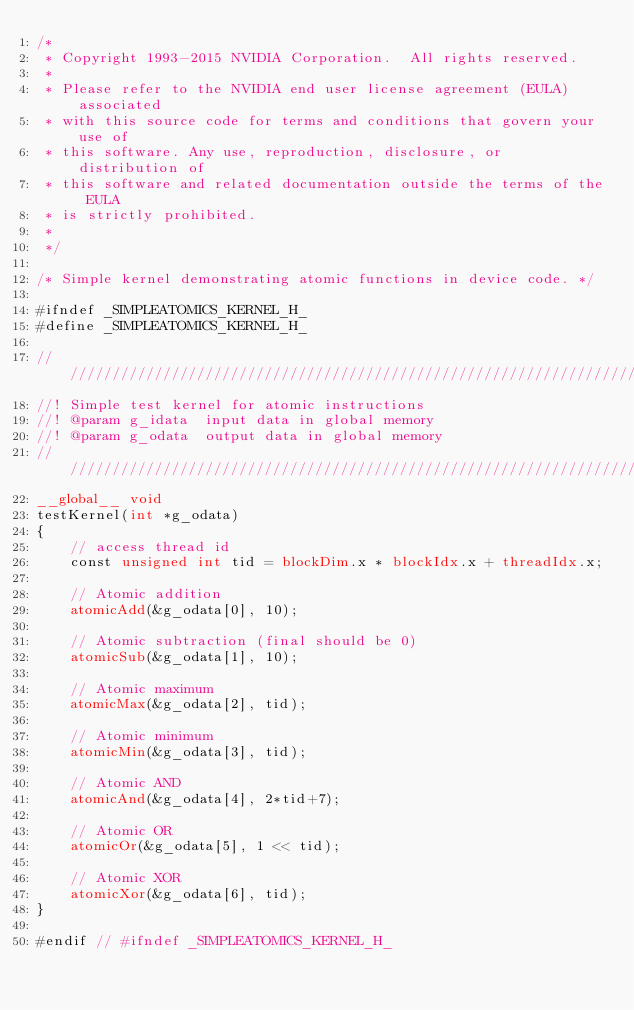<code> <loc_0><loc_0><loc_500><loc_500><_Cuda_>/*
 * Copyright 1993-2015 NVIDIA Corporation.  All rights reserved.
 *
 * Please refer to the NVIDIA end user license agreement (EULA) associated
 * with this source code for terms and conditions that govern your use of
 * this software. Any use, reproduction, disclosure, or distribution of
 * this software and related documentation outside the terms of the EULA
 * is strictly prohibited.
 *
 */

/* Simple kernel demonstrating atomic functions in device code. */

#ifndef _SIMPLEATOMICS_KERNEL_H_
#define _SIMPLEATOMICS_KERNEL_H_

////////////////////////////////////////////////////////////////////////////////
//! Simple test kernel for atomic instructions
//! @param g_idata  input data in global memory
//! @param g_odata  output data in global memory
////////////////////////////////////////////////////////////////////////////////
__global__ void
testKernel(int *g_odata)
{
    // access thread id
    const unsigned int tid = blockDim.x * blockIdx.x + threadIdx.x;

    // Atomic addition
    atomicAdd(&g_odata[0], 10);

    // Atomic subtraction (final should be 0)
    atomicSub(&g_odata[1], 10);

    // Atomic maximum
    atomicMax(&g_odata[2], tid);

    // Atomic minimum
    atomicMin(&g_odata[3], tid);

    // Atomic AND
    atomicAnd(&g_odata[4], 2*tid+7);

    // Atomic OR
    atomicOr(&g_odata[5], 1 << tid);

    // Atomic XOR
    atomicXor(&g_odata[6], tid);
}

#endif // #ifndef _SIMPLEATOMICS_KERNEL_H_
</code> 